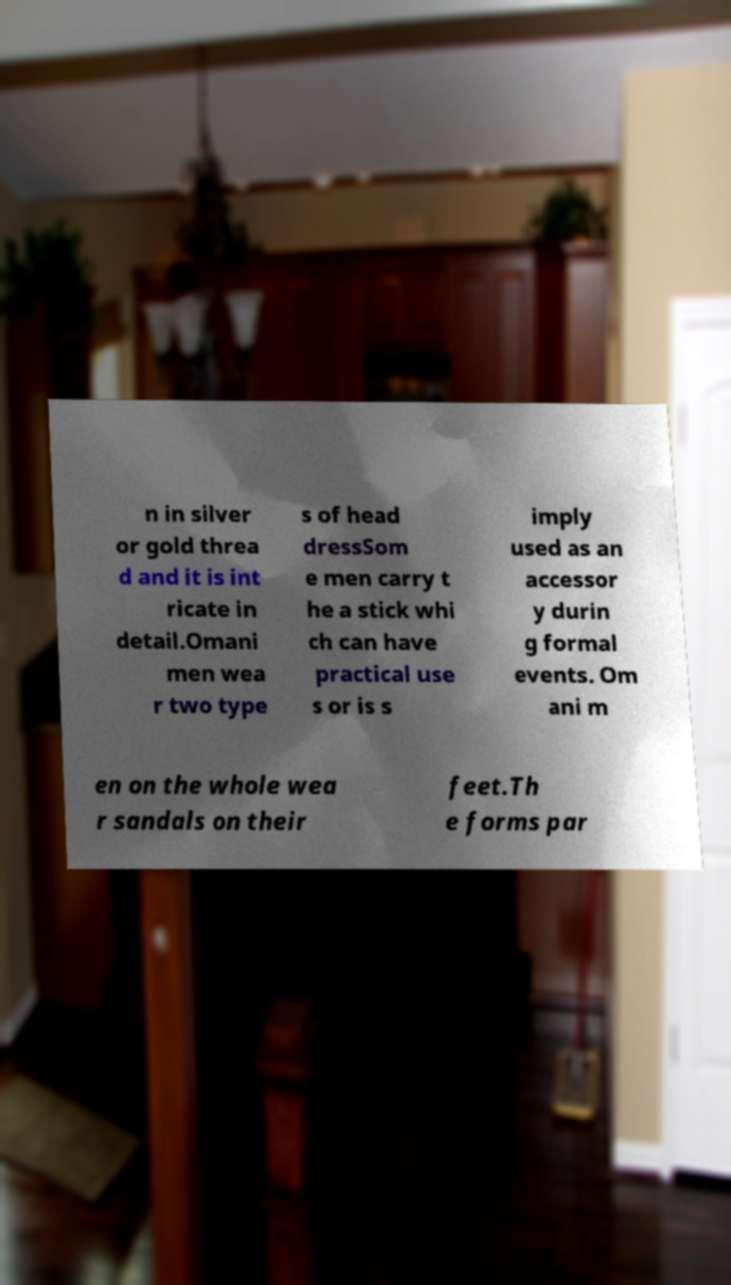Can you read and provide the text displayed in the image?This photo seems to have some interesting text. Can you extract and type it out for me? n in silver or gold threa d and it is int ricate in detail.Omani men wea r two type s of head dressSom e men carry t he a stick whi ch can have practical use s or is s imply used as an accessor y durin g formal events. Om ani m en on the whole wea r sandals on their feet.Th e forms par 